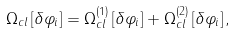Convert formula to latex. <formula><loc_0><loc_0><loc_500><loc_500>\Omega _ { c l } \left [ \delta \varphi _ { i } \right ] = \Omega ^ { ( 1 ) } _ { c l } \left [ \delta \varphi _ { i } \right ] + \Omega ^ { ( 2 ) } _ { c l } \left [ \delta \varphi _ { i } \right ] ,</formula> 